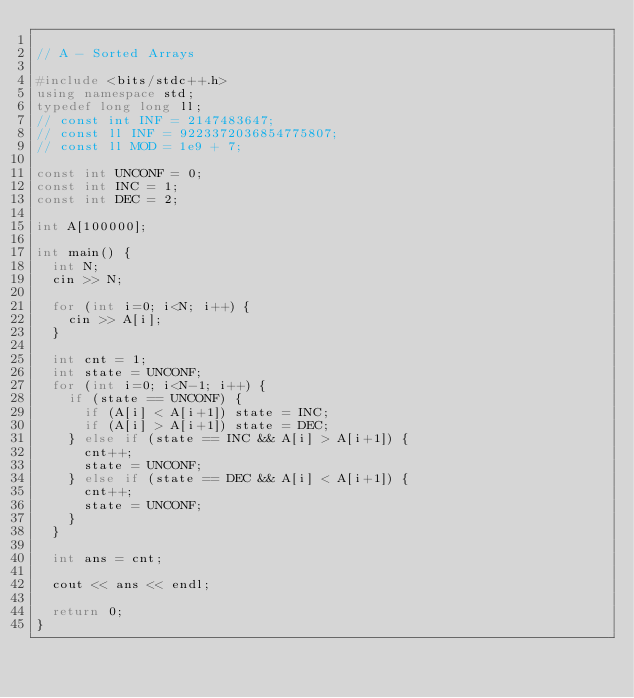<code> <loc_0><loc_0><loc_500><loc_500><_C++_>
// A - Sorted Arrays

#include <bits/stdc++.h>
using namespace std;
typedef long long ll;
// const int INF = 2147483647;
// const ll INF = 9223372036854775807;
// const ll MOD = 1e9 + 7;

const int UNCONF = 0;
const int INC = 1;
const int DEC = 2;

int A[100000];

int main() {
	int N;
	cin >> N;

	for (int i=0; i<N; i++) {
		cin >> A[i];
	}

	int cnt = 1;
	int state = UNCONF;
	for (int i=0; i<N-1; i++) {
		if (state == UNCONF) {
			if (A[i] < A[i+1]) state = INC;
			if (A[i] > A[i+1]) state = DEC;
		} else if (state == INC && A[i] > A[i+1]) {
			cnt++;
			state = UNCONF;
		} else if (state == DEC && A[i] < A[i+1]) {
			cnt++;
			state = UNCONF;
		}
	}

	int ans = cnt;

	cout << ans << endl;

	return 0;
}</code> 